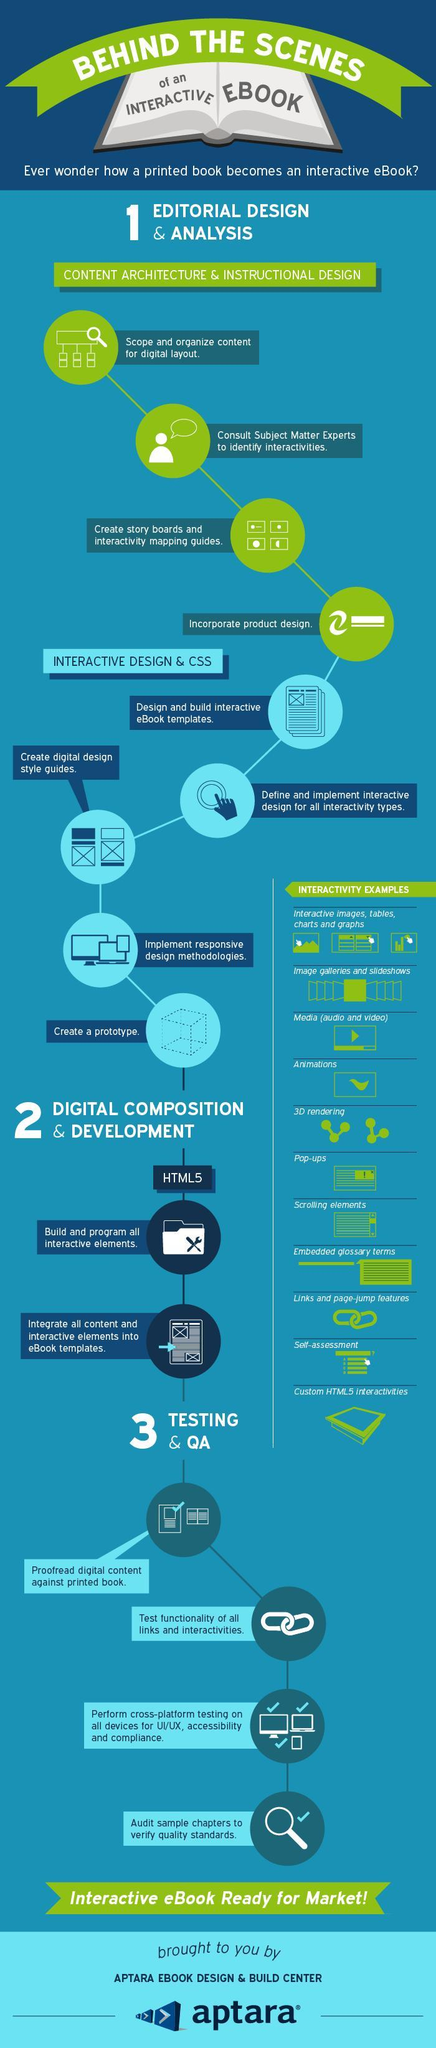what is the second interactivity example given in the list?
Answer the question with a short phrase. image galleries and slideshows what is the next main step after digital composition and development? testing & QA what needs to be done after Integrating all content and all interactive elements into e-book templates? proofread digital content against printed book what is to be followed after creating digital design style guides? implement responsive design methodologies what is the final step under testing? audit sample chapters to verify quality standards what needs to be done after programming all interactive elements? Integrate all content and all interactive elements into e-book templates what is the first step in the process of content architecture and instructional design? scope and organize content for digital layout what is the next step after designing e-book template? design and implement interactive design for all interactivity types what is the final step under interactive design and css? create a prototype what is the fourth interactivity example given in the list? animations 